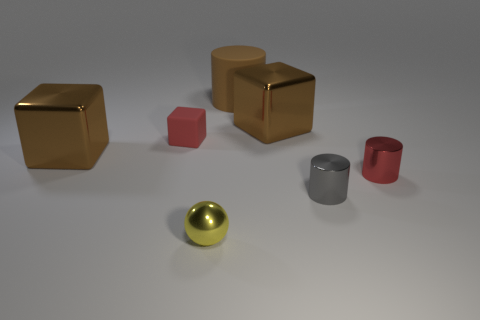Add 1 brown cubes. How many objects exist? 8 Subtract all balls. How many objects are left? 6 Add 7 big blocks. How many big blocks are left? 9 Add 6 big blue cylinders. How many big blue cylinders exist? 6 Subtract 0 cyan balls. How many objects are left? 7 Subtract all metal things. Subtract all tiny red things. How many objects are left? 0 